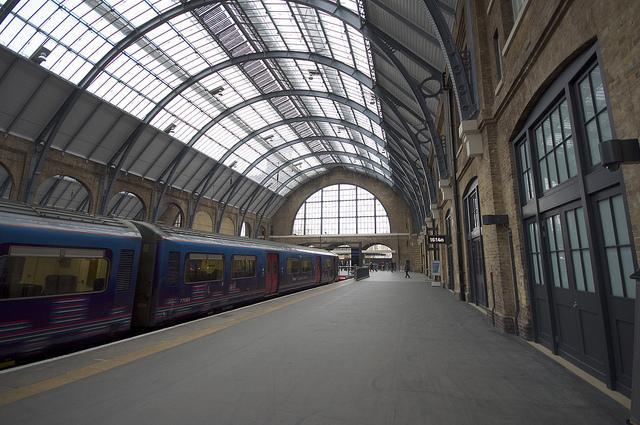What kind of payment is needed for an opportunity to ride this machine? ticket 